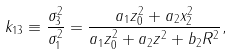<formula> <loc_0><loc_0><loc_500><loc_500>k _ { 1 3 } \equiv \frac { \sigma ^ { 2 } _ { 3 } } { \sigma ^ { 2 } _ { 1 } } = \frac { a _ { 1 } z ^ { 2 } _ { 0 } + a _ { 2 } x ^ { 2 } _ { 2 } } { a _ { 1 } z ^ { 2 } _ { 0 } + a _ { 2 } z ^ { 2 } + b _ { 2 } R ^ { 2 } } ,</formula> 